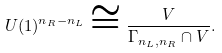Convert formula to latex. <formula><loc_0><loc_0><loc_500><loc_500>U ( 1 ) ^ { n _ { R } - n _ { L } } \cong \frac { V } { \Gamma _ { n _ { L } , n _ { R } } \cap V } .</formula> 